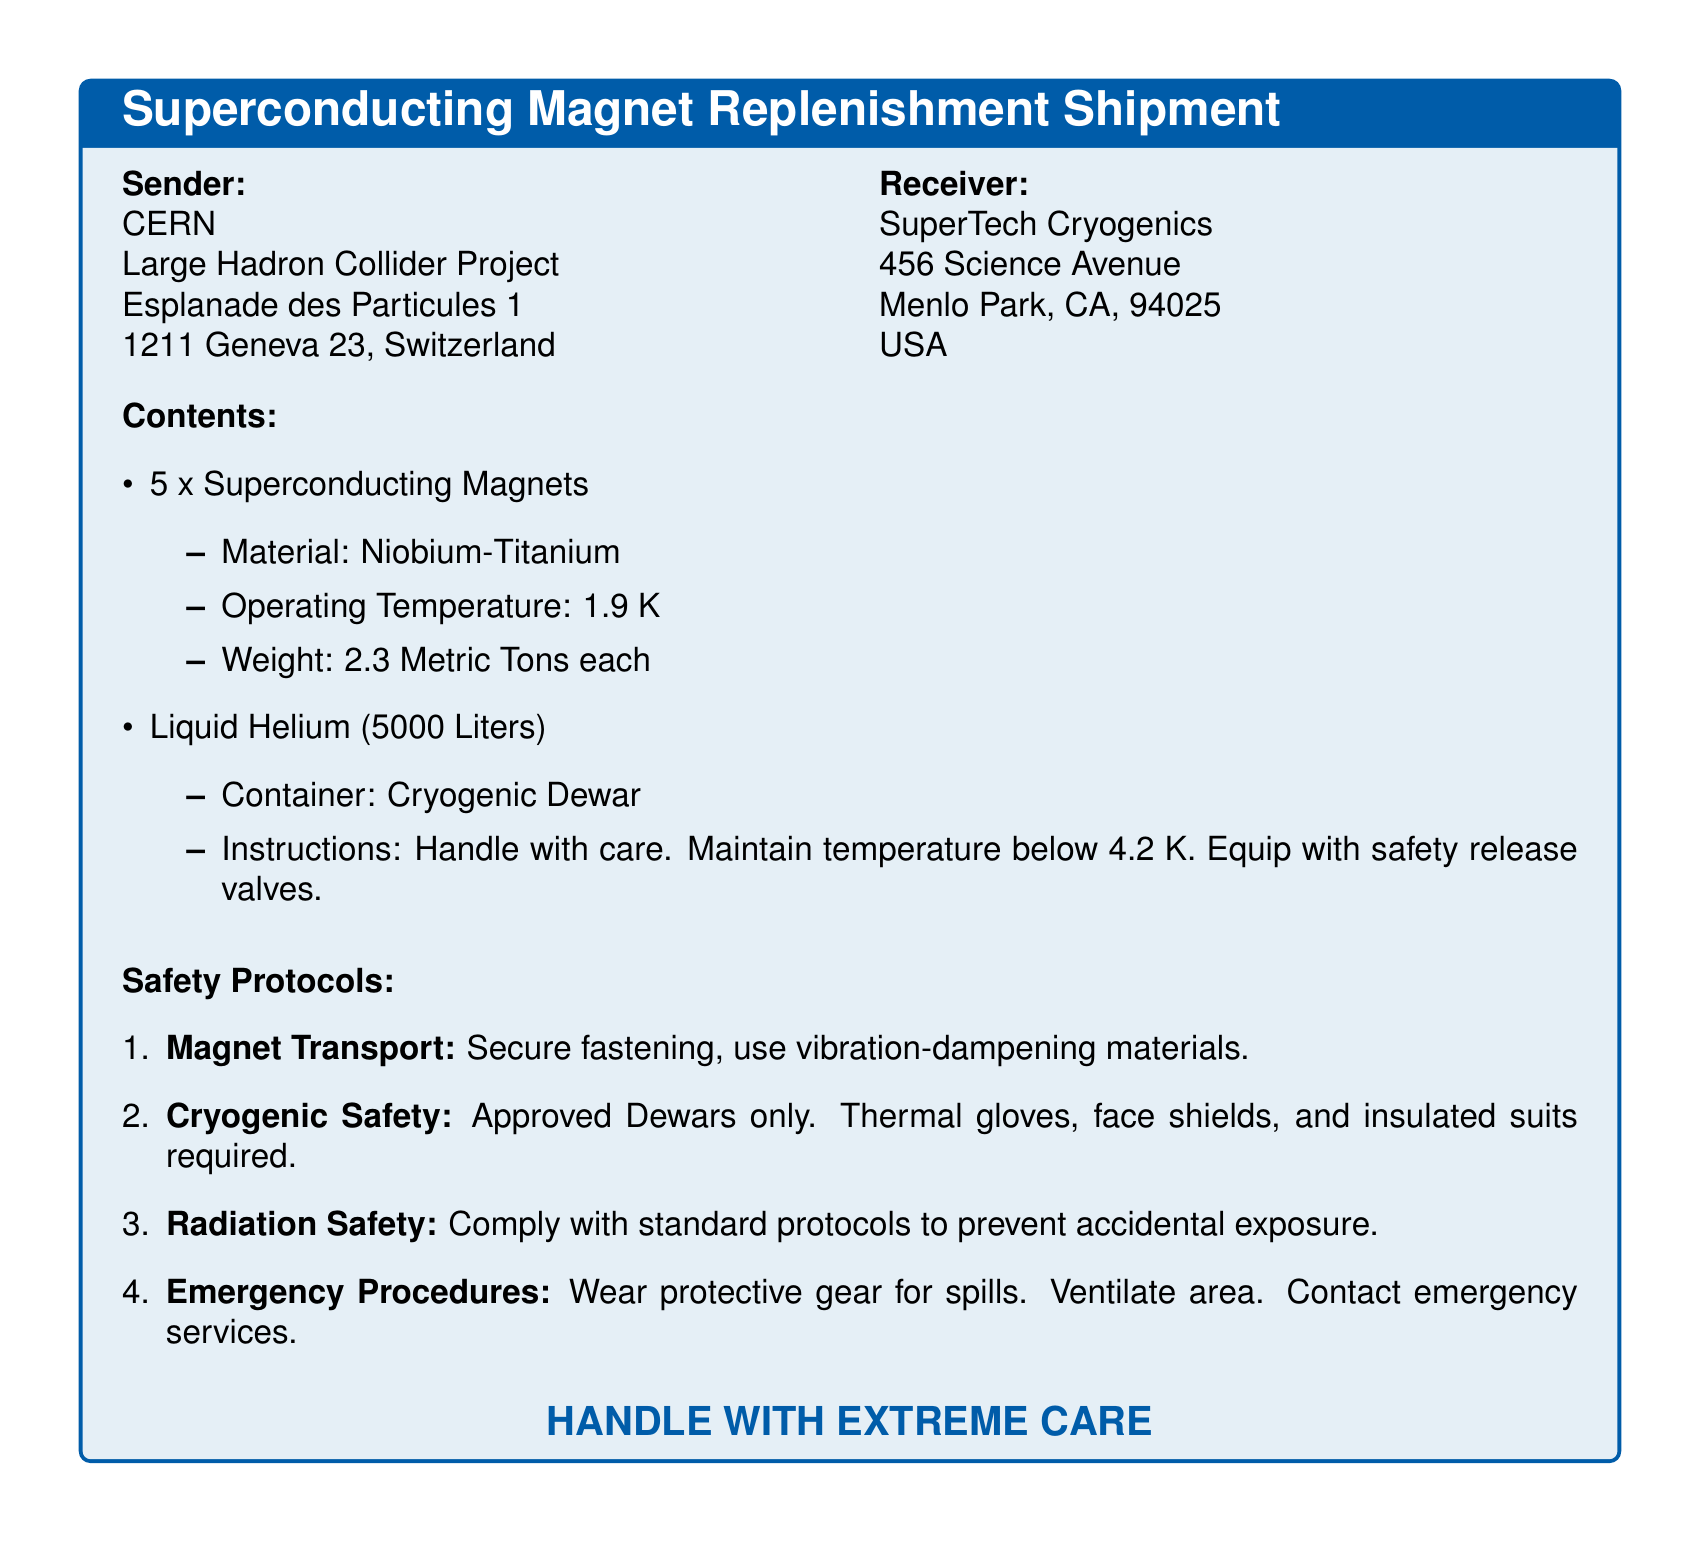What is the sender's name? The sender is CERN, as indicated at the top of the document.
Answer: CERN How many superconducting magnets are being shipped? The document explicitly states that there are 5 superconducting magnets included in the shipment.
Answer: 5 What is the weight of each superconducting magnet? The weight for each superconducting magnet is specified as 2.3 Metric Tons in the document.
Answer: 2.3 Metric Tons What material is used for the superconducting magnets? The document clearly states that the superconducting magnets are made of Niobium-Titanium.
Answer: Niobium-Titanium What is the required operating temperature for the magnets? The document specifies that the operating temperature for the magnets is 1.9 K.
Answer: 1.9 K What safety gear is required for cryogenic safety? The document lists thermal gloves, face shields, and insulated suits as required safety gear.
Answer: Thermal gloves, face shields, insulated suits How many liters of liquid helium are included in the shipment? The document indicates that there are 5000 Liters of liquid helium included.
Answer: 5000 Liters What type of container is used for the liquid helium? The document specifies that a Cryogenic Dewar is used for the liquid helium.
Answer: Cryogenic Dewar What should be done in the case of a spill according to the emergency procedures? The document states that protective gear should be worn for spills and the area should be ventilated.
Answer: Wear protective gear, ventilate area 